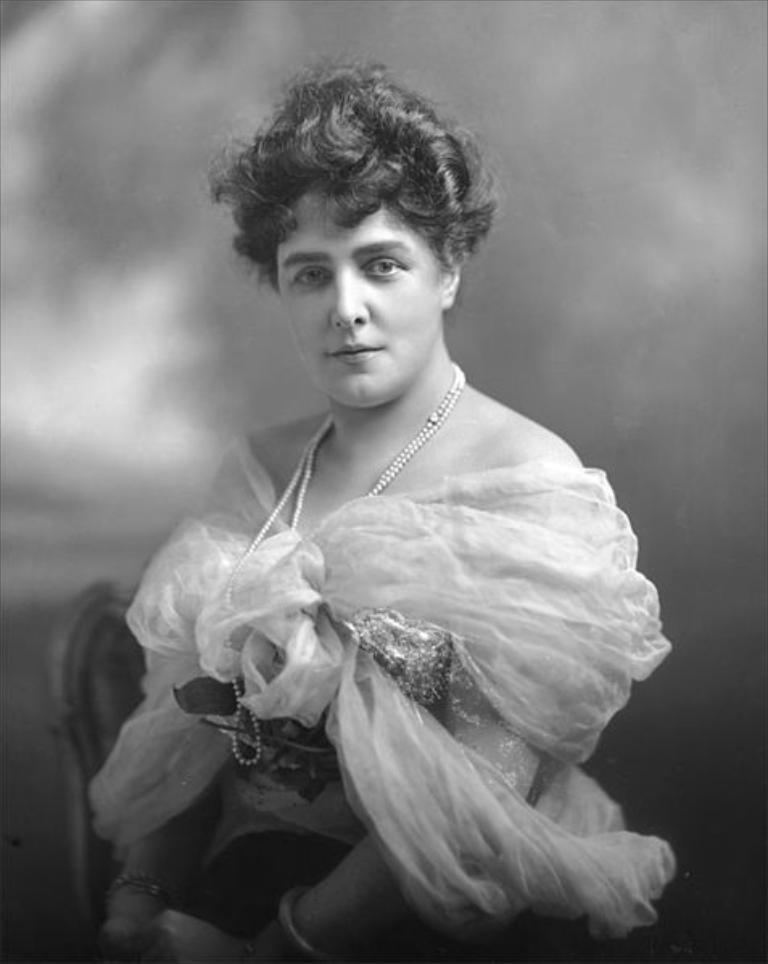Who is present in the image? There is a lady in the image. What can be seen on the left side of the image? There is a chair on the left side of the image. Where is the house located in the image? There is no house present in the image. Can you see a trail in the image? There is no trail visible in the image. Is there a chicken in the image? There is no chicken present in the image. 